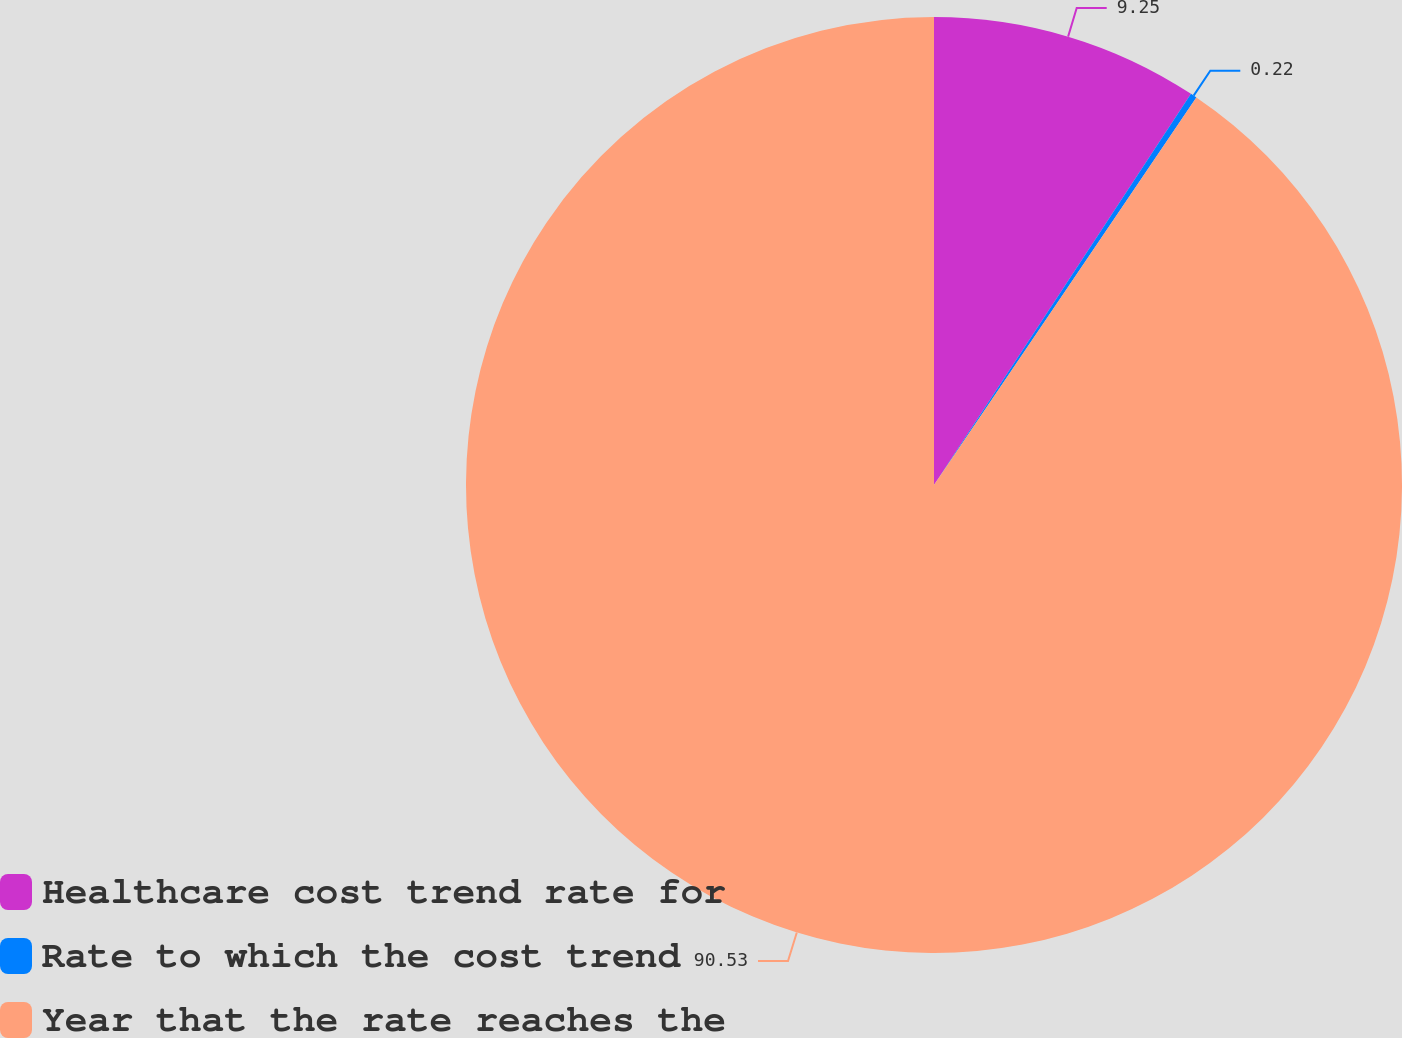Convert chart. <chart><loc_0><loc_0><loc_500><loc_500><pie_chart><fcel>Healthcare cost trend rate for<fcel>Rate to which the cost trend<fcel>Year that the rate reaches the<nl><fcel>9.25%<fcel>0.22%<fcel>90.52%<nl></chart> 